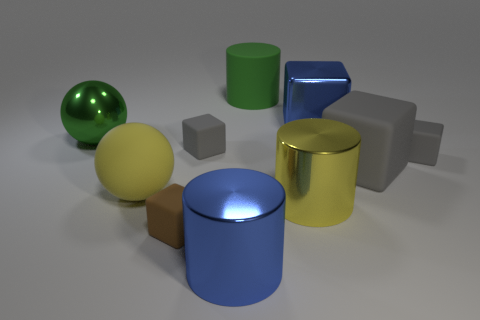Do the metal ball and the big matte cylinder have the same color?
Your answer should be very brief. Yes. There is a thing that is behind the blue metallic object behind the large blue shiny thing that is left of the blue shiny cube; what is it made of?
Your answer should be compact. Rubber. How many objects are tiny brown rubber things or tiny shiny cylinders?
Keep it short and to the point. 1. There is a object in front of the brown object; is it the same color as the big cube that is behind the big matte cube?
Offer a terse response. Yes. What shape is the yellow metal object that is the same size as the green sphere?
Offer a terse response. Cylinder. How many objects are large rubber objects that are on the left side of the blue cylinder or gray matte blocks on the left side of the big yellow shiny cylinder?
Offer a terse response. 2. Are there fewer large gray rubber things than small red shiny cylinders?
Give a very brief answer. No. What material is the blue cylinder that is the same size as the matte sphere?
Offer a terse response. Metal. There is a gray matte thing that is to the right of the big matte cube; does it have the same size as the cylinder that is behind the large shiny sphere?
Your answer should be very brief. No. Are there any green objects made of the same material as the yellow cylinder?
Offer a very short reply. Yes. 